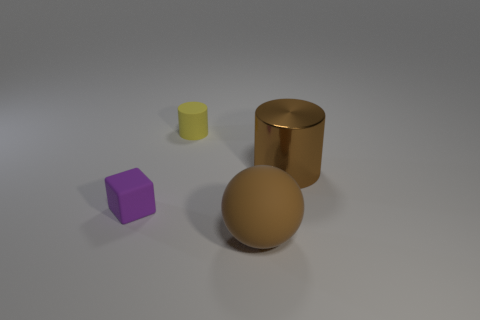Add 3 big spheres. How many objects exist? 7 Subtract all balls. How many objects are left? 3 Add 3 yellow objects. How many yellow objects exist? 4 Subtract 0 green blocks. How many objects are left? 4 Subtract all brown spheres. Subtract all brown things. How many objects are left? 1 Add 2 rubber cylinders. How many rubber cylinders are left? 3 